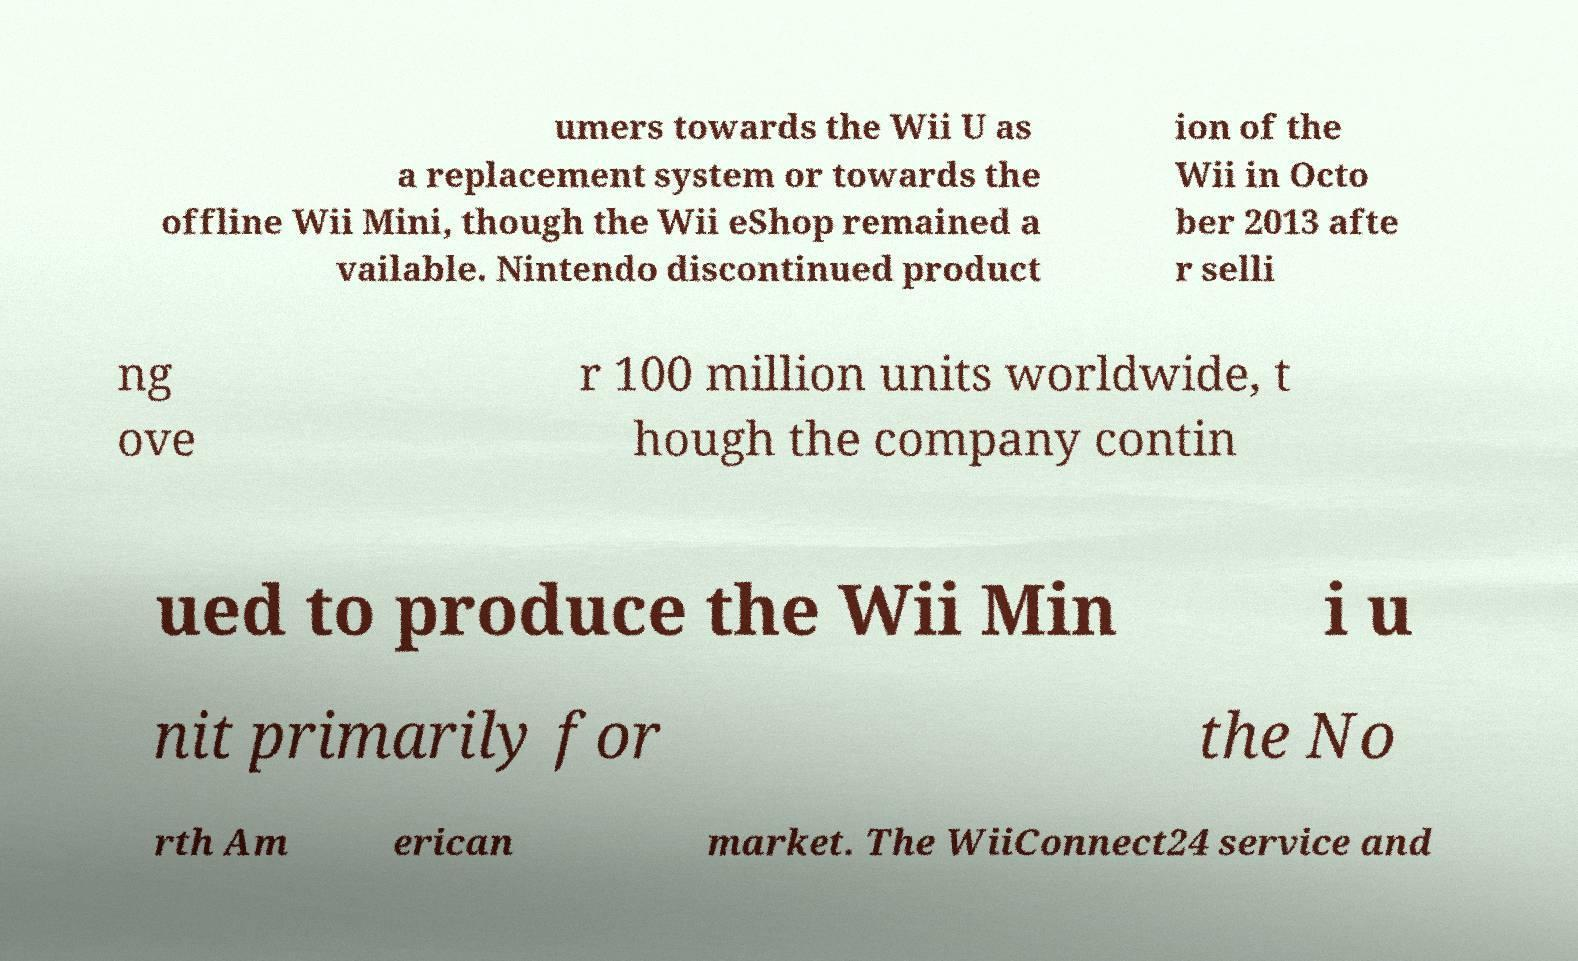Can you accurately transcribe the text from the provided image for me? umers towards the Wii U as a replacement system or towards the offline Wii Mini, though the Wii eShop remained a vailable. Nintendo discontinued product ion of the Wii in Octo ber 2013 afte r selli ng ove r 100 million units worldwide, t hough the company contin ued to produce the Wii Min i u nit primarily for the No rth Am erican market. The WiiConnect24 service and 